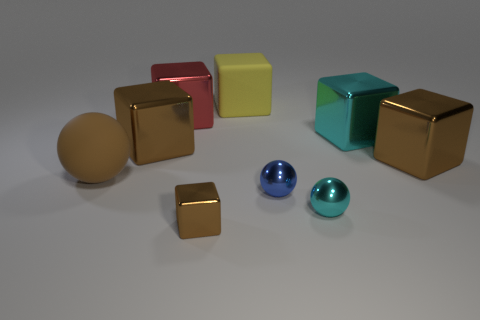What number of other things are there of the same size as the red block? In the image, there are three other blocks that appear to be of the same size as the red one: a yellow block, a teal block, and one of the golden blocks. 